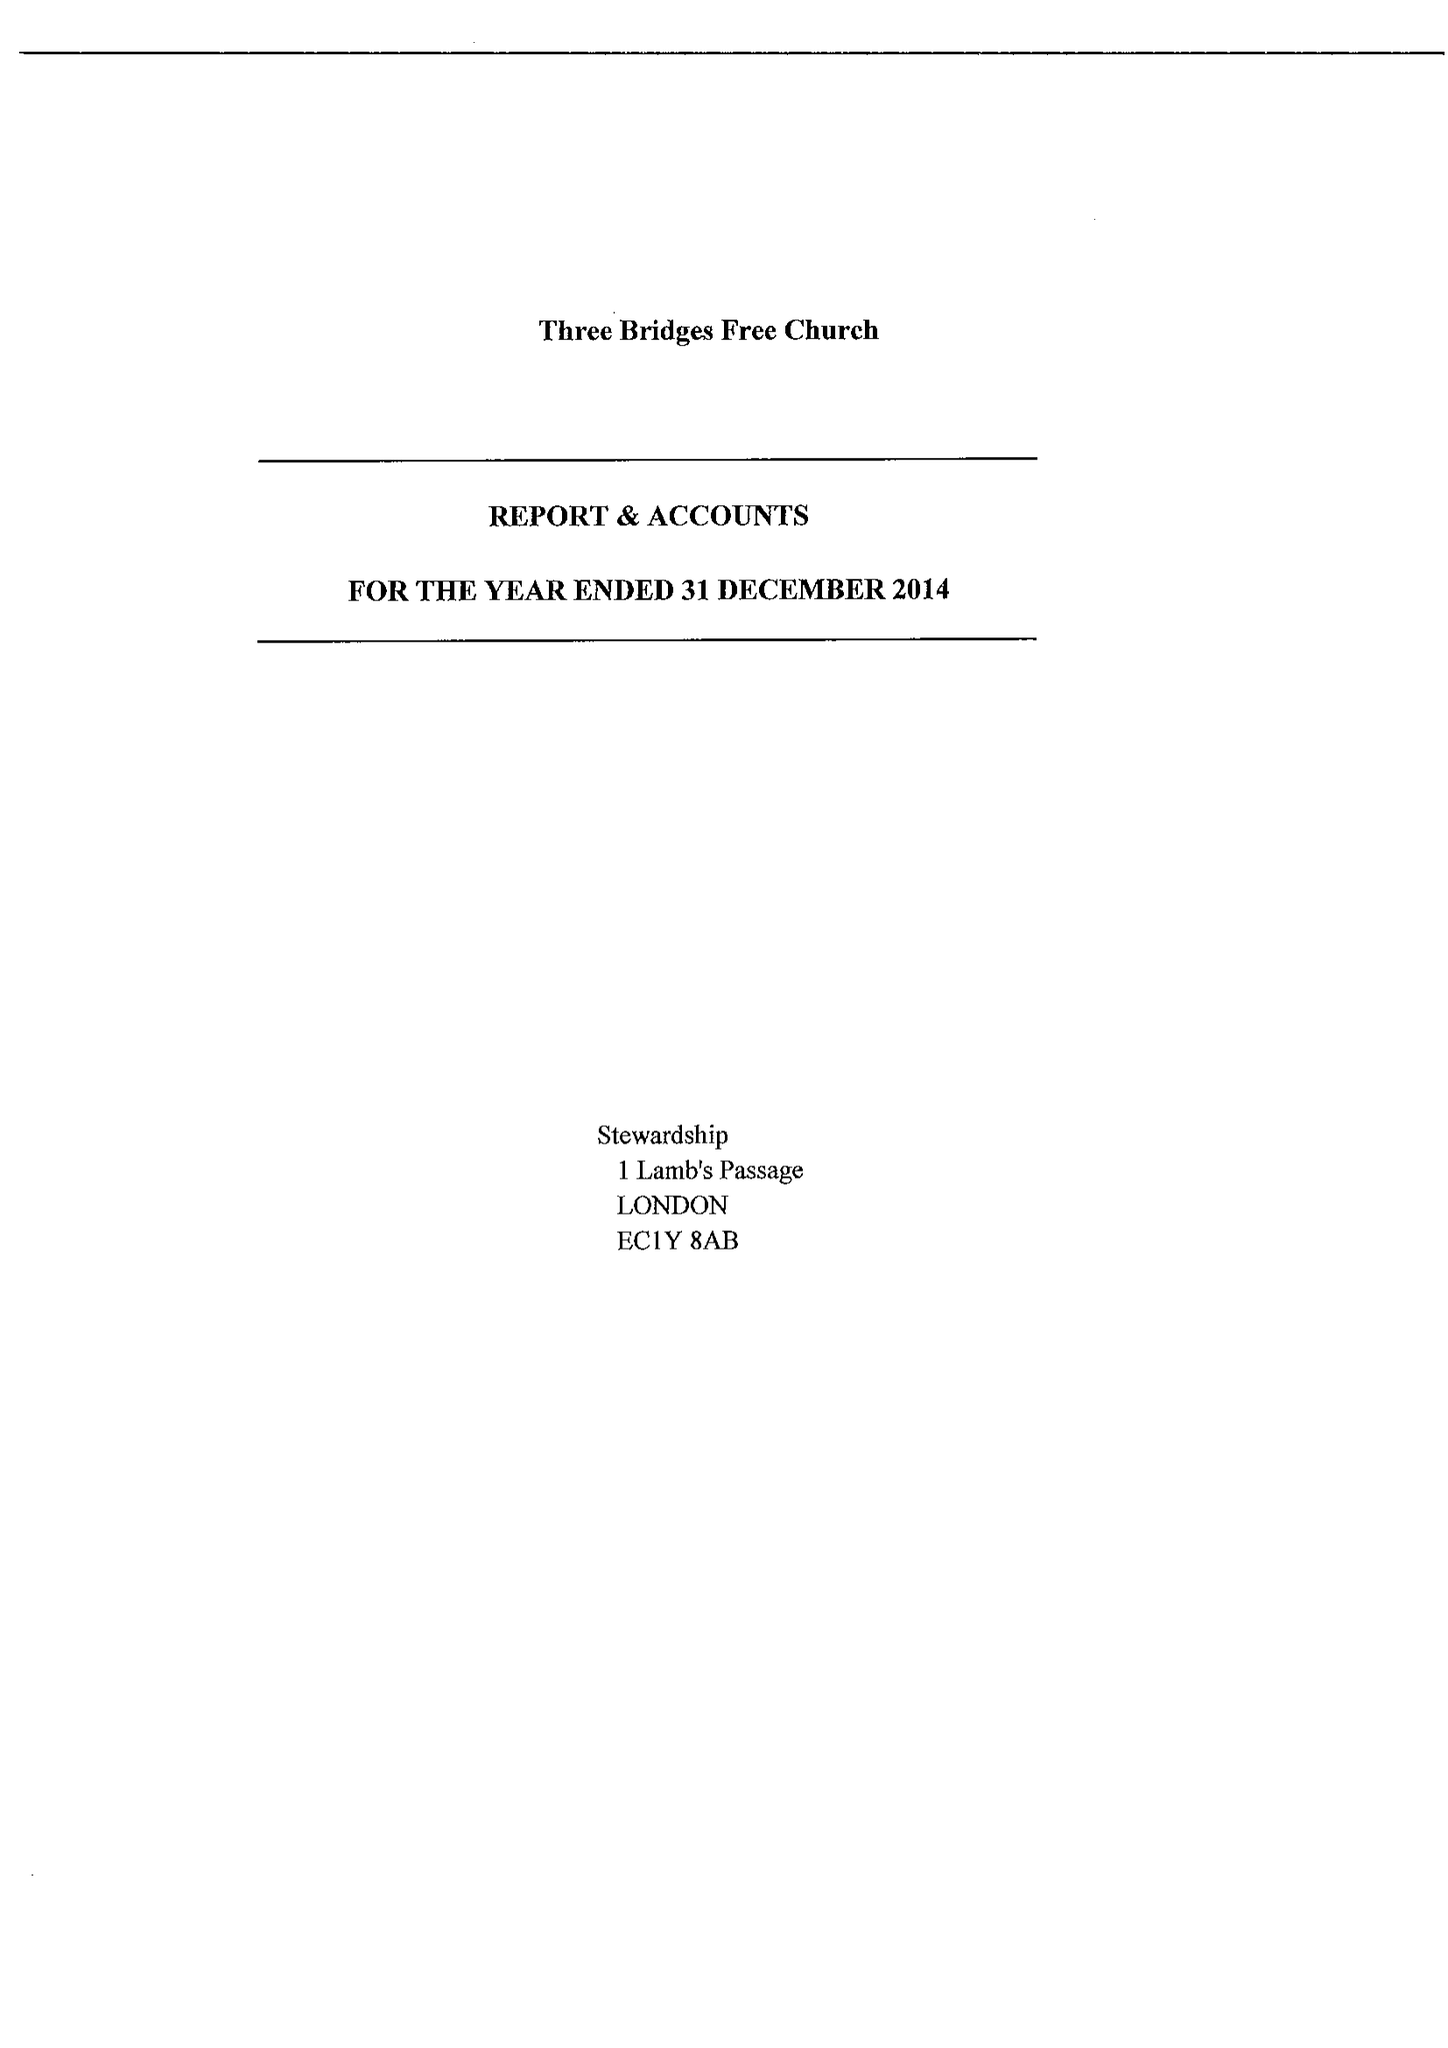What is the value for the address__postcode?
Answer the question using a single word or phrase. RH10 1LS 